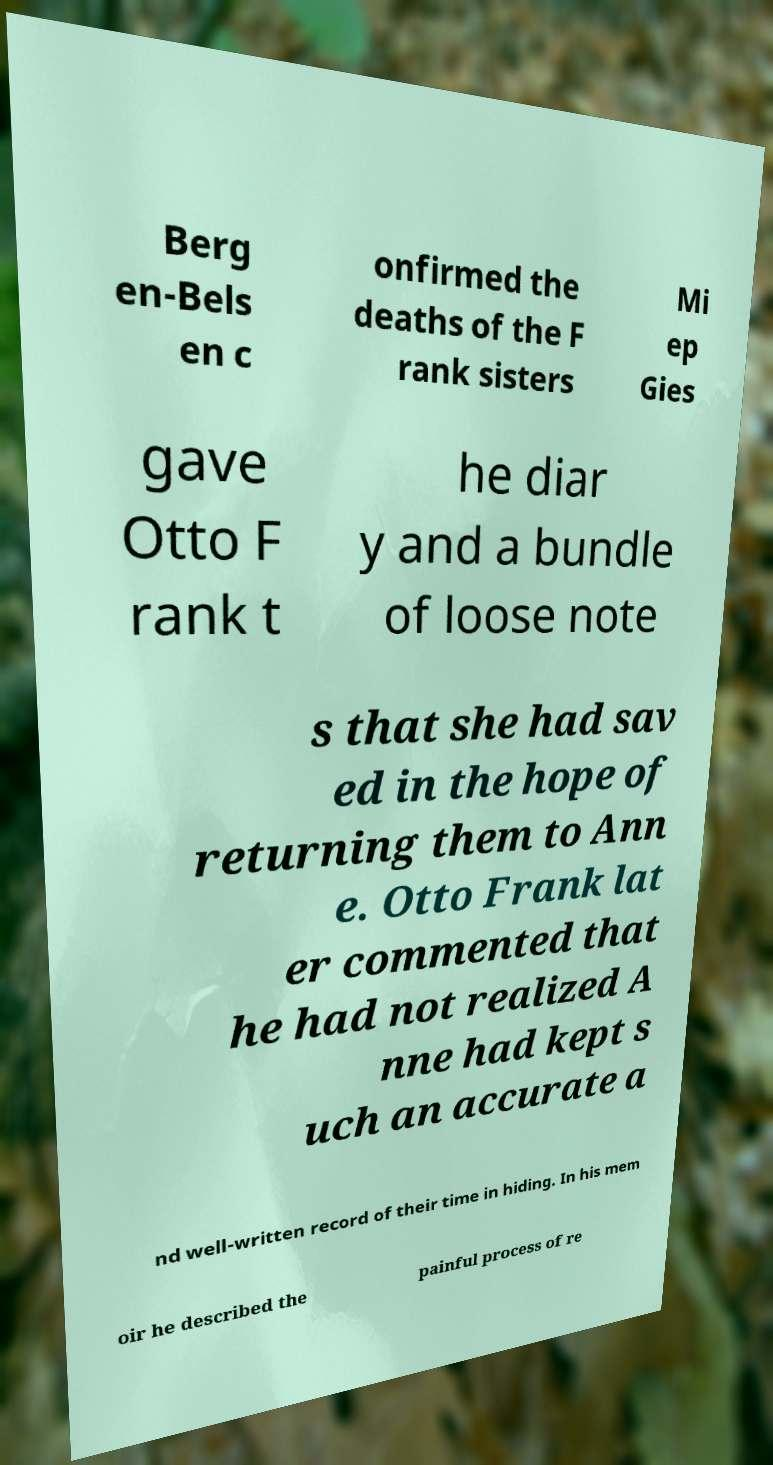Please read and relay the text visible in this image. What does it say? Berg en-Bels en c onfirmed the deaths of the F rank sisters Mi ep Gies gave Otto F rank t he diar y and a bundle of loose note s that she had sav ed in the hope of returning them to Ann e. Otto Frank lat er commented that he had not realized A nne had kept s uch an accurate a nd well-written record of their time in hiding. In his mem oir he described the painful process of re 